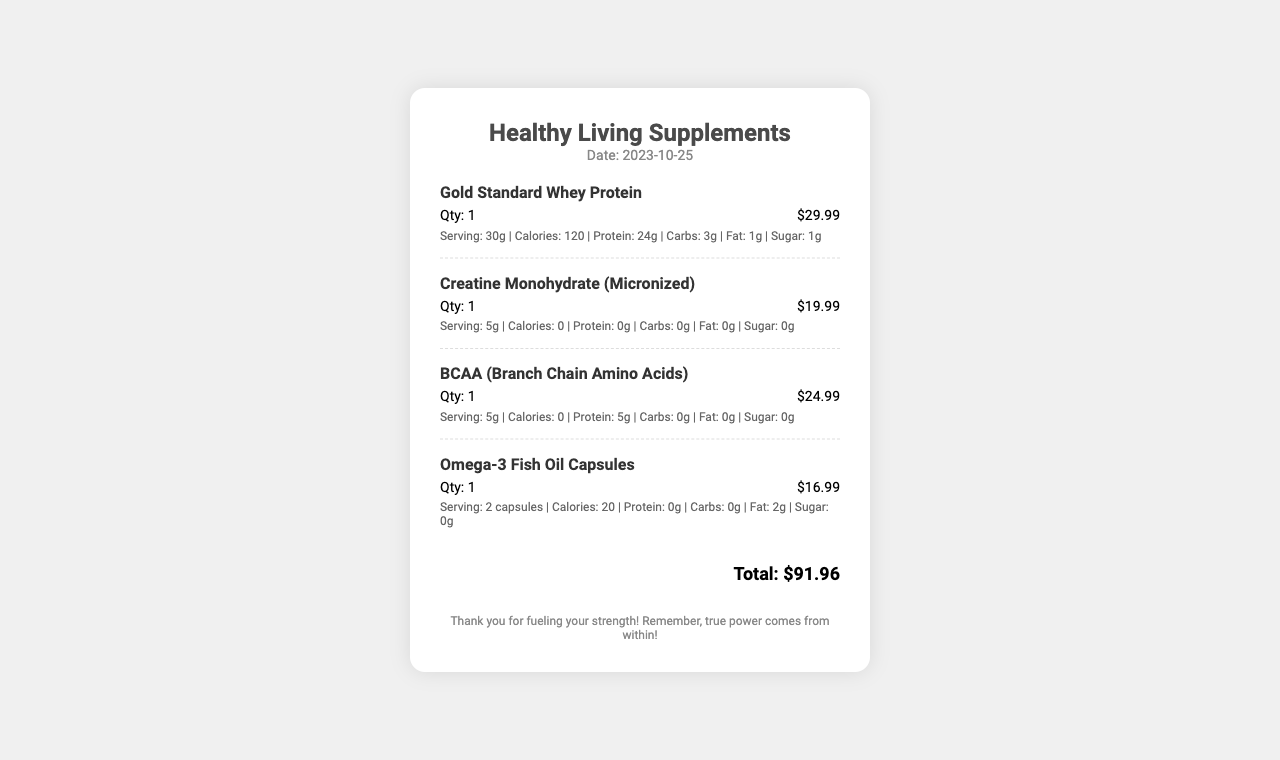what is the store name? The store name is located at the top of the receipt.
Answer: Healthy Living Supplements what is the date of purchase? The date of purchase is specified near the store name.
Answer: 2023-10-25 how many items were purchased? The total number of items can be counted from the item list in the receipt.
Answer: 4 what is the price of Gold Standard Whey Protein? The price of Gold Standard Whey Protein is indicated next to its name.
Answer: $29.99 what is the total amount spent? The total amount is calculated and displayed at the bottom of the receipt.
Answer: $91.96 which item has the highest protein content per serving? The item with the highest protein content can be determined by comparing the protein values in the nutritional information.
Answer: Gold Standard Whey Protein how much does the Creatine Monohydrate cost? The cost of the Creatine Monohydrate can be found next to its name in the item list.
Answer: $19.99 what is the serving size of Omega-3 Fish Oil Capsules? The serving size is noted in the nutritional information section for Omega-3 Fish Oil Capsules.
Answer: 2 capsules which item contains zero calories? The items that have zero calories are indicated in their nutritional information.
Answer: Creatine Monohydrate, BCAA 